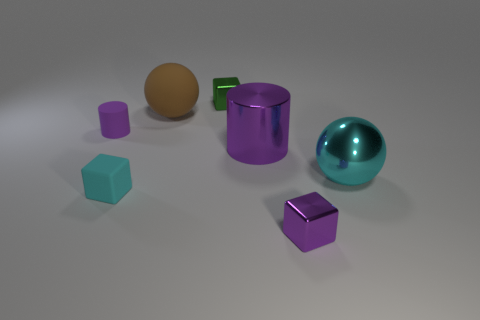Subtract all cyan cubes. How many cubes are left? 2 Add 1 tiny red metal balls. How many objects exist? 8 Subtract all cubes. How many objects are left? 4 Subtract 2 blocks. How many blocks are left? 1 Subtract all gray cubes. Subtract all blue spheres. How many cubes are left? 3 Subtract all brown rubber spheres. Subtract all purple metal cylinders. How many objects are left? 5 Add 3 small green things. How many small green things are left? 4 Add 1 purple rubber objects. How many purple rubber objects exist? 2 Subtract 0 green cylinders. How many objects are left? 7 